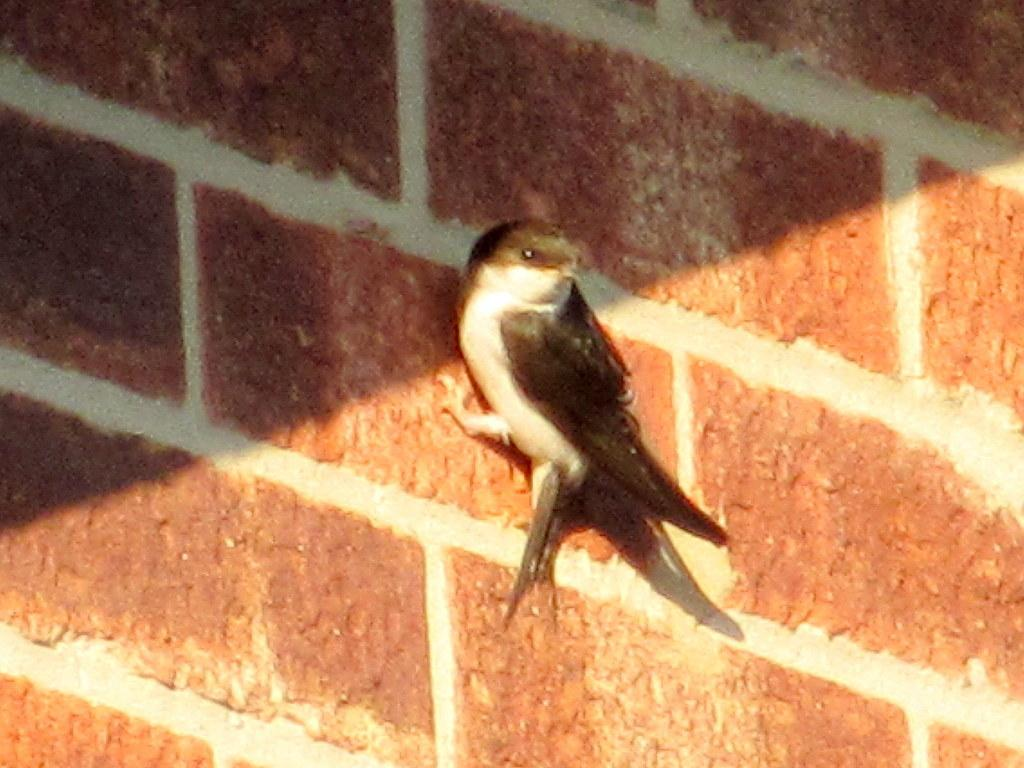What type of animal is present in the image? There is a bird in the image. What is the bird standing on in the image? The bird is standing on a stone floor. What type of dress is the bird wearing in the image? There is no dress present in the image, as the bird is a bird and not a person. Can you see any signs of birth in the image? There is no indication of birth in the image; it features a bird standing on a stone floor. 